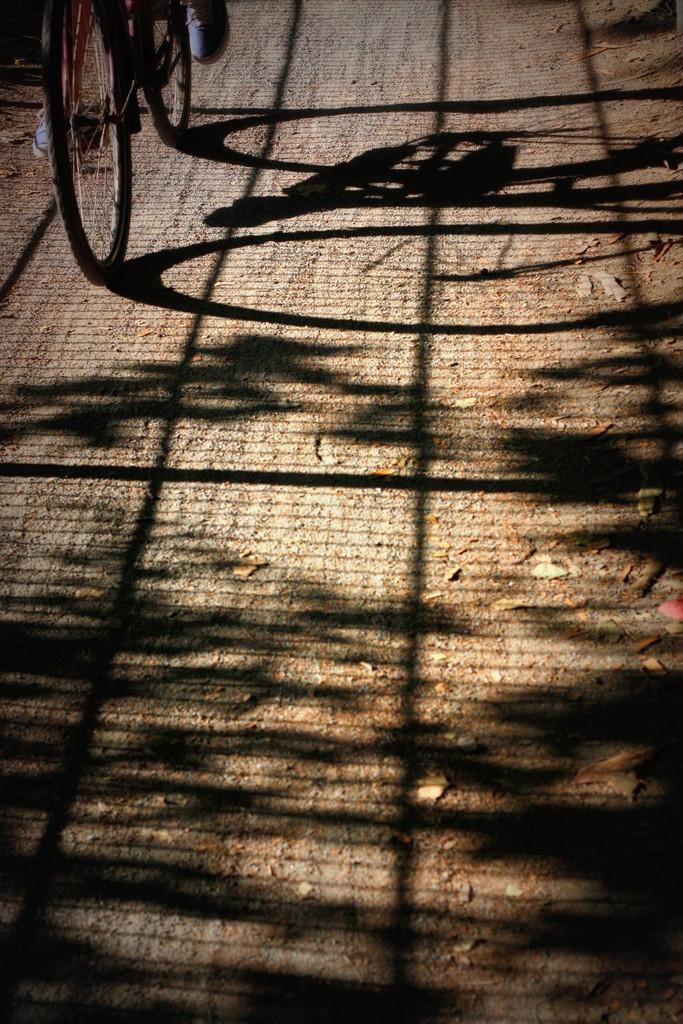Describe this image in one or two sentences. In the top left corner of the image a person is riding a bicycle. In the middle of the image we can see a shadow. 